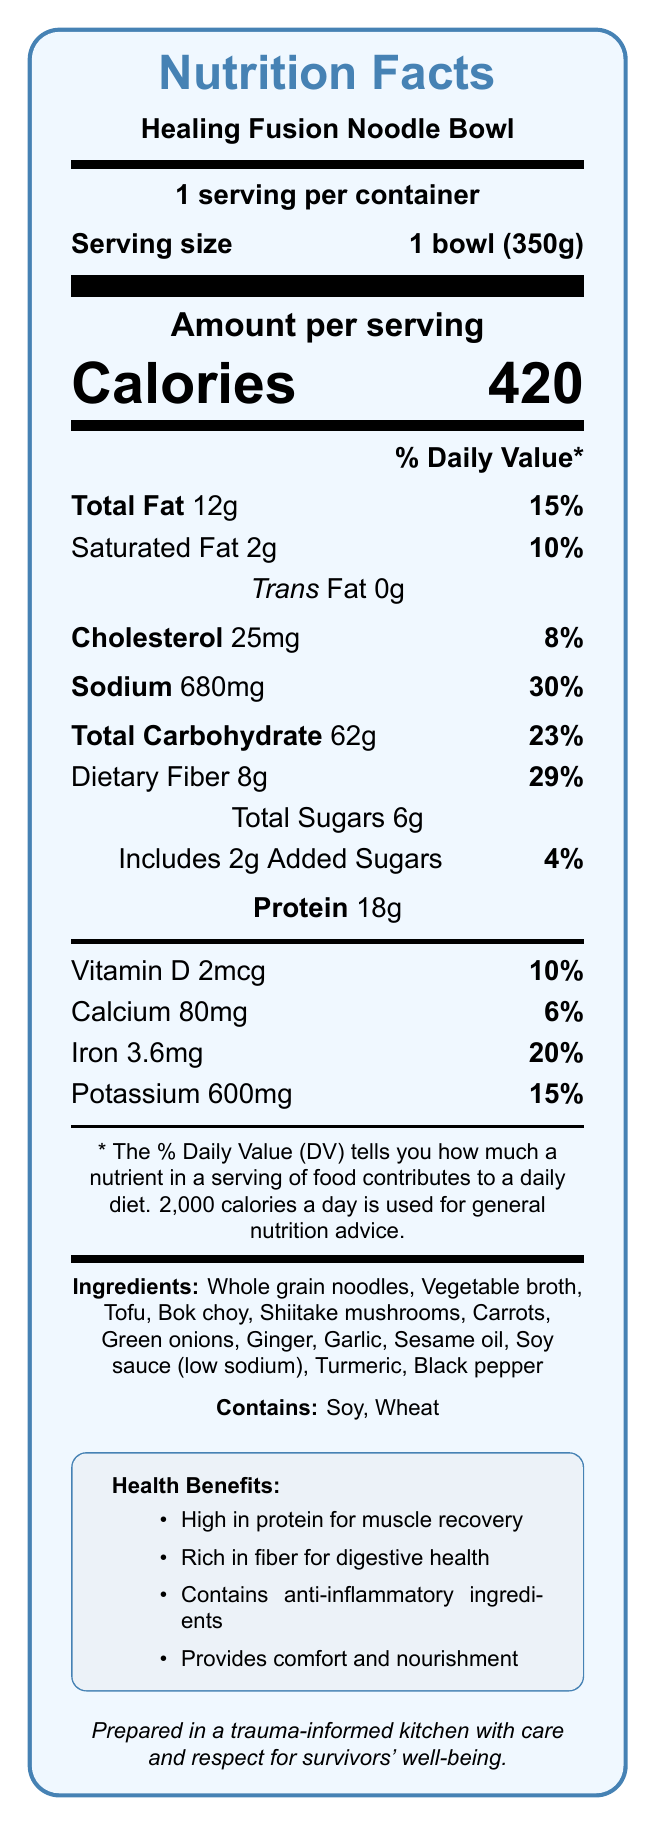what is the serving size for the Healing Fusion Noodle Bowl? The serving size is stated directly in the document under the "Serving size" heading.
Answer: 1 bowl (350g) how many calories are in one serving of the Healing Fusion Noodle Bowl? The amount of calories per serving is listed as 420 in the "Calories" section of the document.
Answer: 420 what is the total amount of fat in a serving and its percentage of daily value? The document lists the total fat amount as 12 grams and the daily value percentage as 15%.
Answer: 12g, 15% how much dietary fiber is in one serving? The amount of dietary fiber is specified in the document as 8 grams.
Answer: 8g which vitamins and minerals are included in the nutritional information? The document lists these under their respective sections with amounts and daily value percentages.
Answer: Vitamin D, Calcium, Iron, Potassium what are the main ingredients of the Healing Fusion Noodle Bowl? The "Ingredients" section lists these ingredients.
Answer: Whole grain noodles, Vegetable broth, Tofu, Bok choy, Shiitake mushrooms, Carrots, Green onions, Ginger, Garlic, Sesame oil, Soy sauce (low sodium), Turmeric, Black pepper how much sodium is in the Healing Fusion Noodle Bowl? The sodium content is listed as 680 milligrams.
Answer: 680mg which of the following does the Nutrition Facts label include under total carbohydrate? A. Cholesterol B. Dietary Fiber C. Protein D. Calcium Dietary fiber is listed under the "Total Carbohydrate" section.
Answer: B. Dietary Fiber what percentage of the daily value is the protein content in one serving? A. 10% B. 20% C. Not listed D. 15% The document does not provide the daily value percentage for protein.
Answer: C. Not listed does the Healing Fusion Noodle Bowl contain any allergens? The document lists "Soy" and "Wheat" as allergens.
Answer: Yes does the document describe any cultural or emotional significance of the product? The "cultural_significance" section describes the product as offering a comforting and familiar taste for survivors from diverse backgrounds, providing physical nourishment and emotional comfort.
Answer: Yes summarize the main content of the Nutrition Facts label for the Healing Fusion Noodle Bowl. The summary includes key nutritional elements, ingredients, allergens, health benefits, cultural significance, and preparation notes.
Answer: The document provides nutrition information for the Healing Fusion Noodle Bowl, including serving size (1 bowl, 350g), calories (420), amounts and daily values for fats, cholesterol, sodium, carbohydrates, fibers, sugars, proteins, and several vitamins and minerals. It lists the ingredients, allergens (soy and wheat), health benefits, and cultural significance, emphasizing preparation in a trauma-informed kitchen for the well-being of survivors. how much vitamin D does the Healing Fusion Noodle Bowl contain per serving? The amount of vitamin D is specified in the document.
Answer: 2mcg what is the preparation note mentioned in the document? The preparation note is provided at the end of the document.
Answer: Prepared in a trauma-informed kitchen with care and respect for survivors' well-being. does the Healing Fusion Noodle Bowl contain any trans fat? The document indicates that the trans fat amount is 0 grams.
Answer: No what specific health benefits are mentioned in the document? These health benefits are listed under the "Health Benefits" section.
Answer: High in protein for muscle recovery, Rich in fiber for digestive health, Contains anti-inflammatory ingredients, Provides comfort and nourishment does the document specify the exact amount of protein daily value? The document lists the amount of protein (18g) but does not provide the daily value percentage.
Answer: No, it does not specify the daily value percentage for protein. why is vitamin C content not listed on the label? The document does not mention vitamin C, so there is no information on it.
Answer: I don't know/Not enough information what factors contribute to the sodium content being 30% of the daily value? This requires understanding that the daily value percentages are based on a standard 2000-calorie diet.
Answer: The sodium content of 680mg comprises 30% of the daily value because it is a significant contributor to sodium intake based on a 2000-calorie diet. 